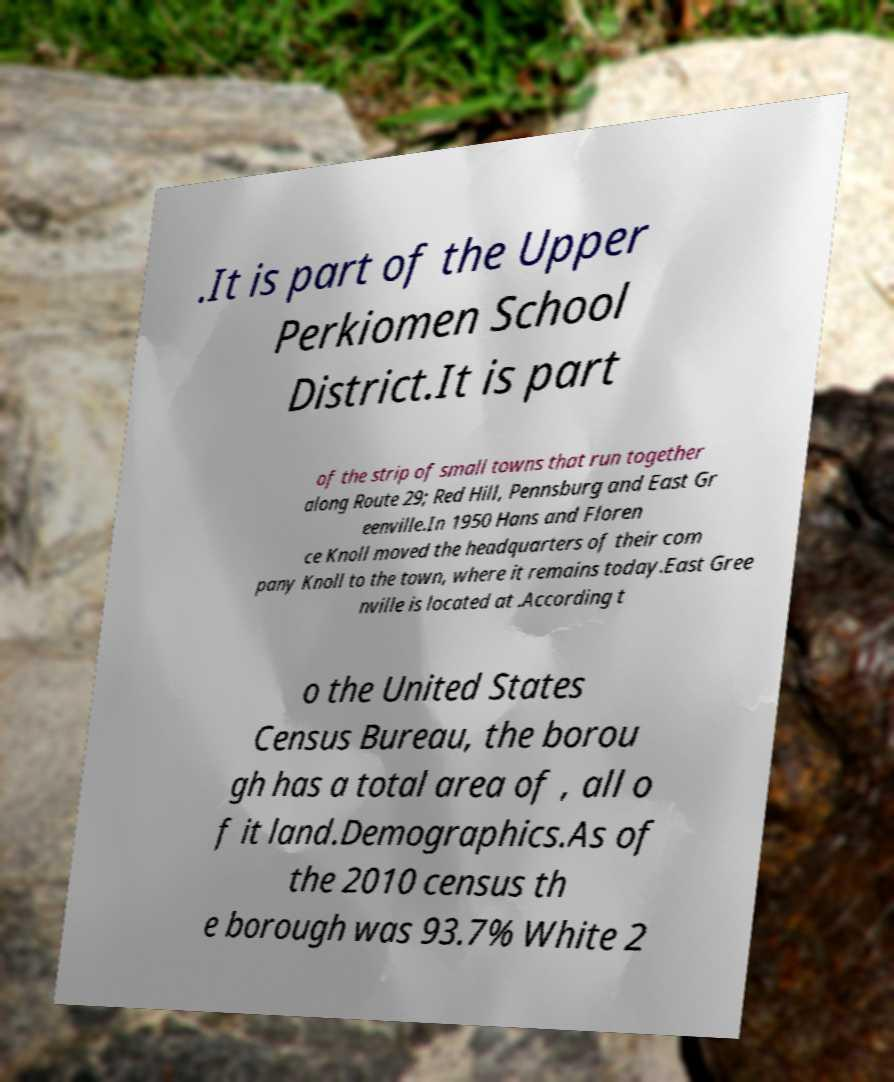I need the written content from this picture converted into text. Can you do that? .It is part of the Upper Perkiomen School District.It is part of the strip of small towns that run together along Route 29; Red Hill, Pennsburg and East Gr eenville.In 1950 Hans and Floren ce Knoll moved the headquarters of their com pany Knoll to the town, where it remains today.East Gree nville is located at .According t o the United States Census Bureau, the borou gh has a total area of , all o f it land.Demographics.As of the 2010 census th e borough was 93.7% White 2 